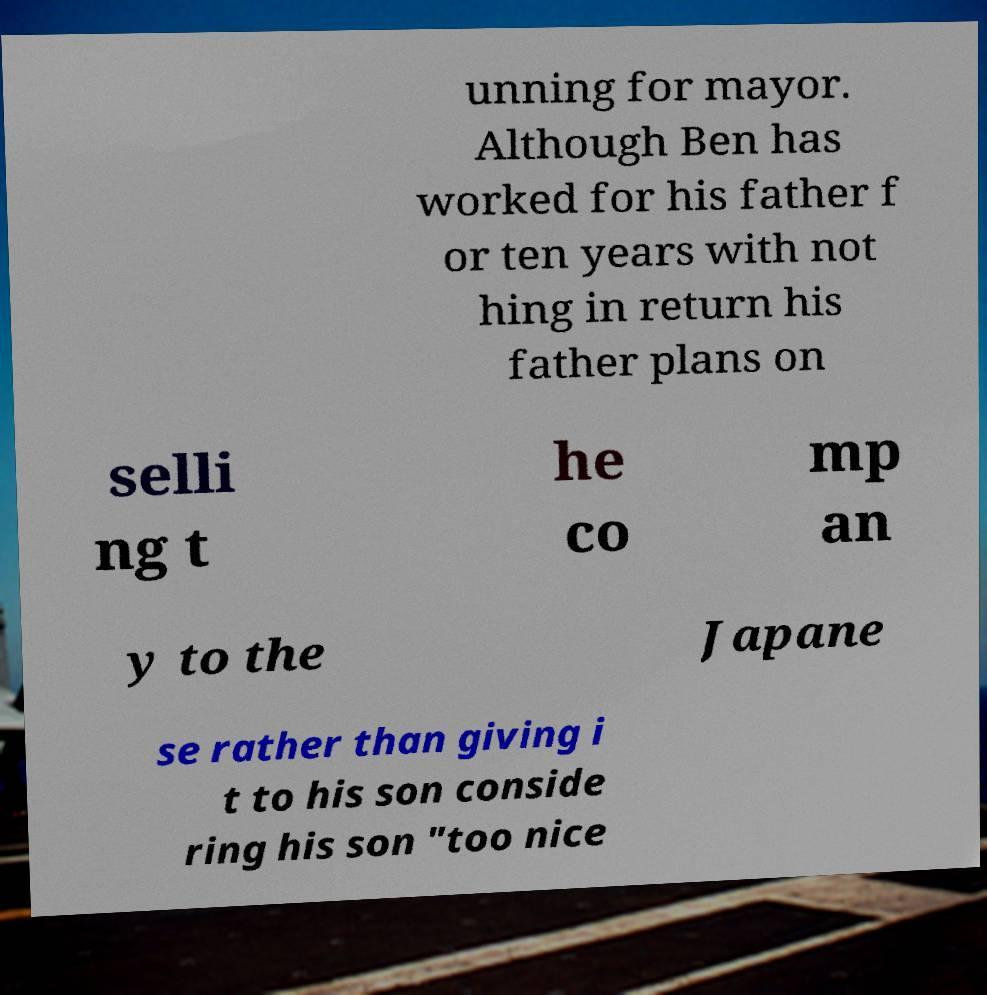Can you accurately transcribe the text from the provided image for me? unning for mayor. Although Ben has worked for his father f or ten years with not hing in return his father plans on selli ng t he co mp an y to the Japane se rather than giving i t to his son conside ring his son "too nice 